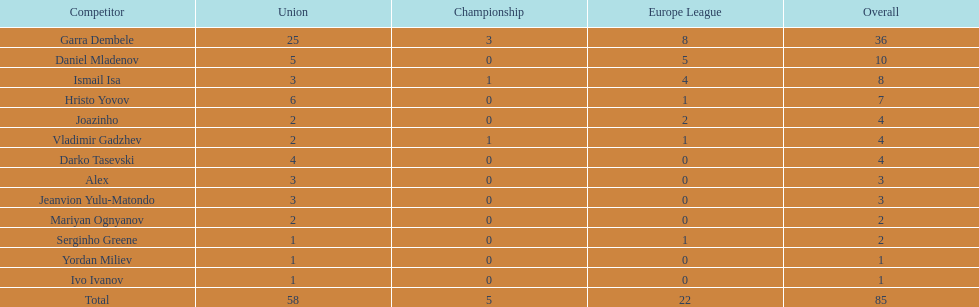How many goals did ismail isa score this season? 8. 